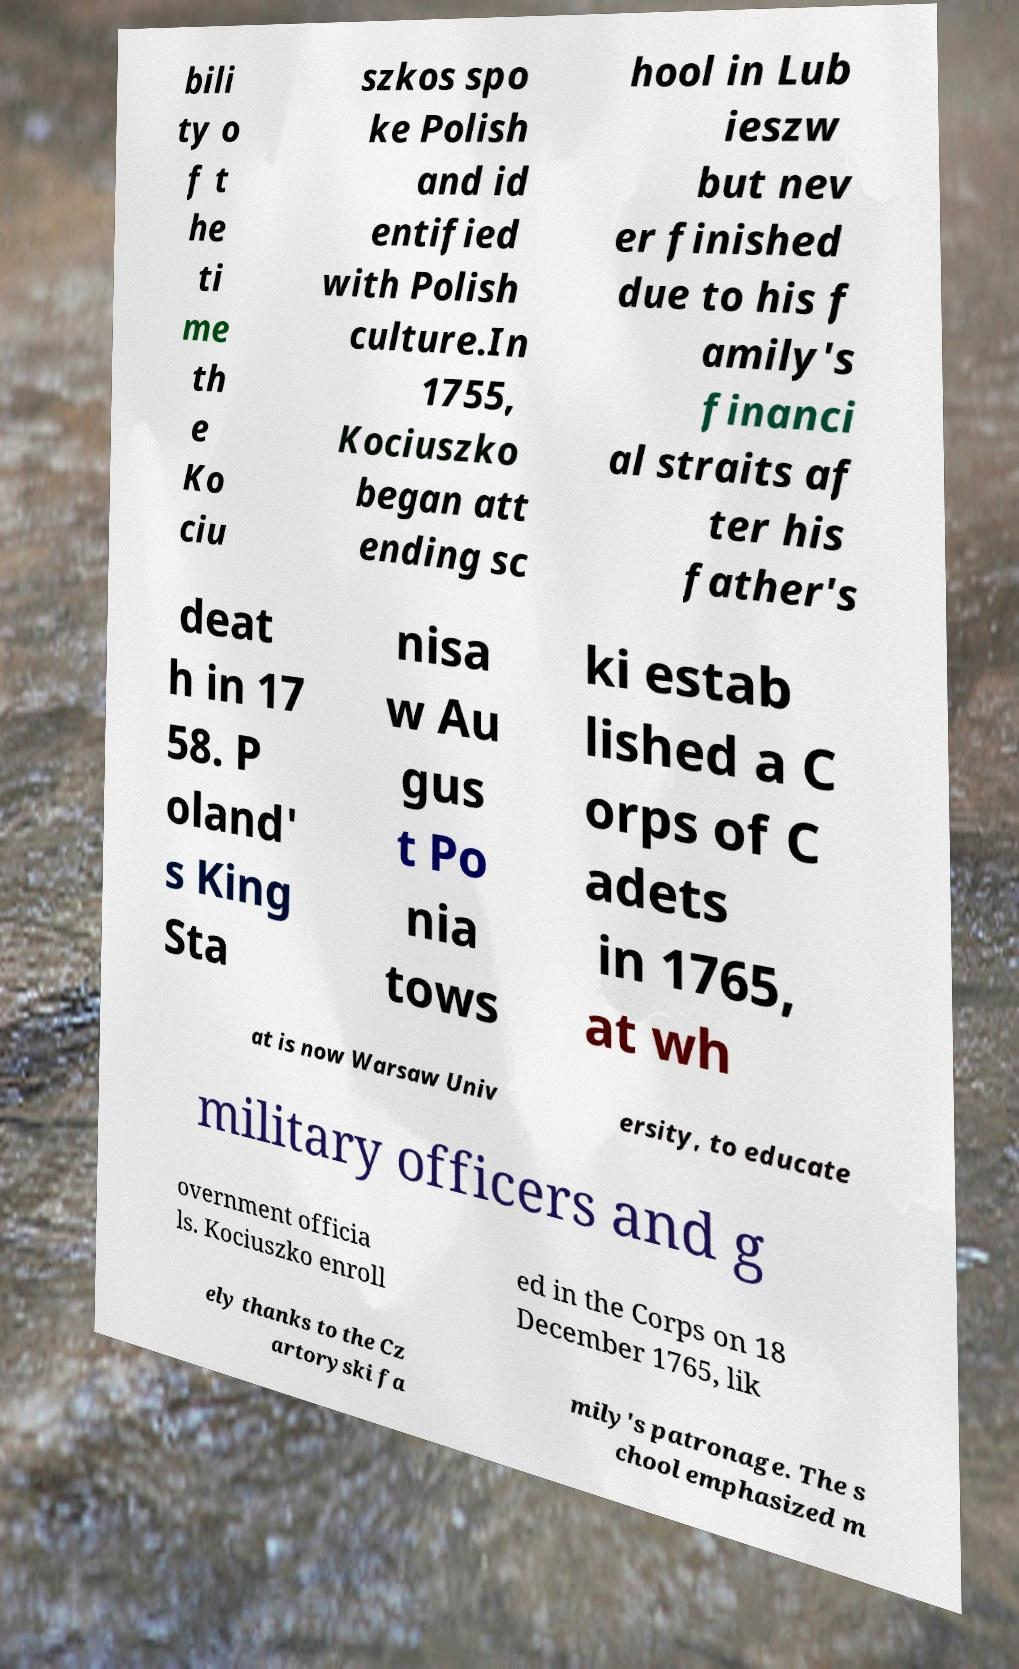For documentation purposes, I need the text within this image transcribed. Could you provide that? bili ty o f t he ti me th e Ko ciu szkos spo ke Polish and id entified with Polish culture.In 1755, Kociuszko began att ending sc hool in Lub ieszw but nev er finished due to his f amily's financi al straits af ter his father's deat h in 17 58. P oland' s King Sta nisa w Au gus t Po nia tows ki estab lished a C orps of C adets in 1765, at wh at is now Warsaw Univ ersity, to educate military officers and g overnment officia ls. Kociuszko enroll ed in the Corps on 18 December 1765, lik ely thanks to the Cz artoryski fa mily's patronage. The s chool emphasized m 